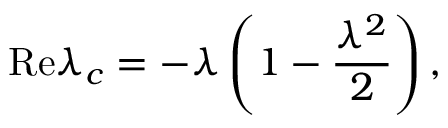Convert formula to latex. <formula><loc_0><loc_0><loc_500><loc_500>R e \lambda _ { c } = - \lambda \left ( 1 - \frac { \lambda ^ { 2 } } { 2 } \right ) ,</formula> 